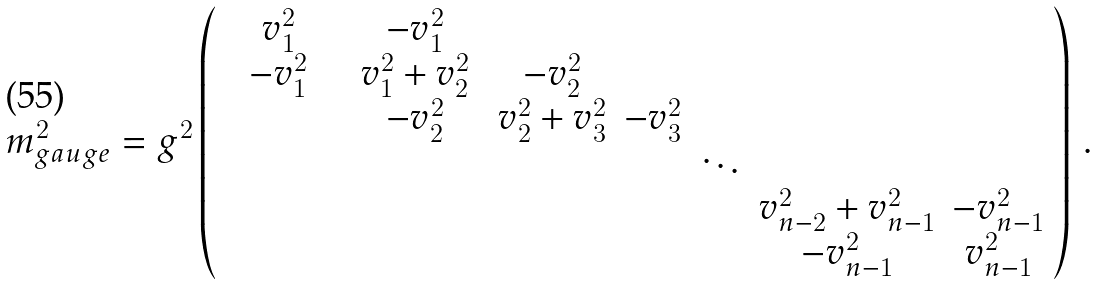Convert formula to latex. <formula><loc_0><loc_0><loc_500><loc_500>m ^ { 2 } _ { g a u g e } = g ^ { 2 } \left ( \begin{array} { c c c c c c c } \quad v ^ { 2 } _ { 1 } \quad & \quad - v ^ { 2 } _ { 1 } \quad & \quad & \quad & \quad & \quad & \\ - v ^ { 2 } _ { 1 } & v ^ { 2 } _ { 1 } + v ^ { 2 } _ { 2 } & - v ^ { 2 } _ { 2 } & & & & \\ & - v ^ { 2 } _ { 2 } & v ^ { 2 } _ { 2 } + v ^ { 2 } _ { 3 } & - v ^ { 2 } _ { 3 } & & & \\ & & & & \ddots & \\ & & & & & v ^ { 2 } _ { n - 2 } + v ^ { 2 } _ { n - 1 } & - v ^ { 2 } _ { n - 1 } \\ & & & & & - v ^ { 2 } _ { n - 1 } & v ^ { 2 } _ { n - 1 } \end{array} \right ) \, .</formula> 